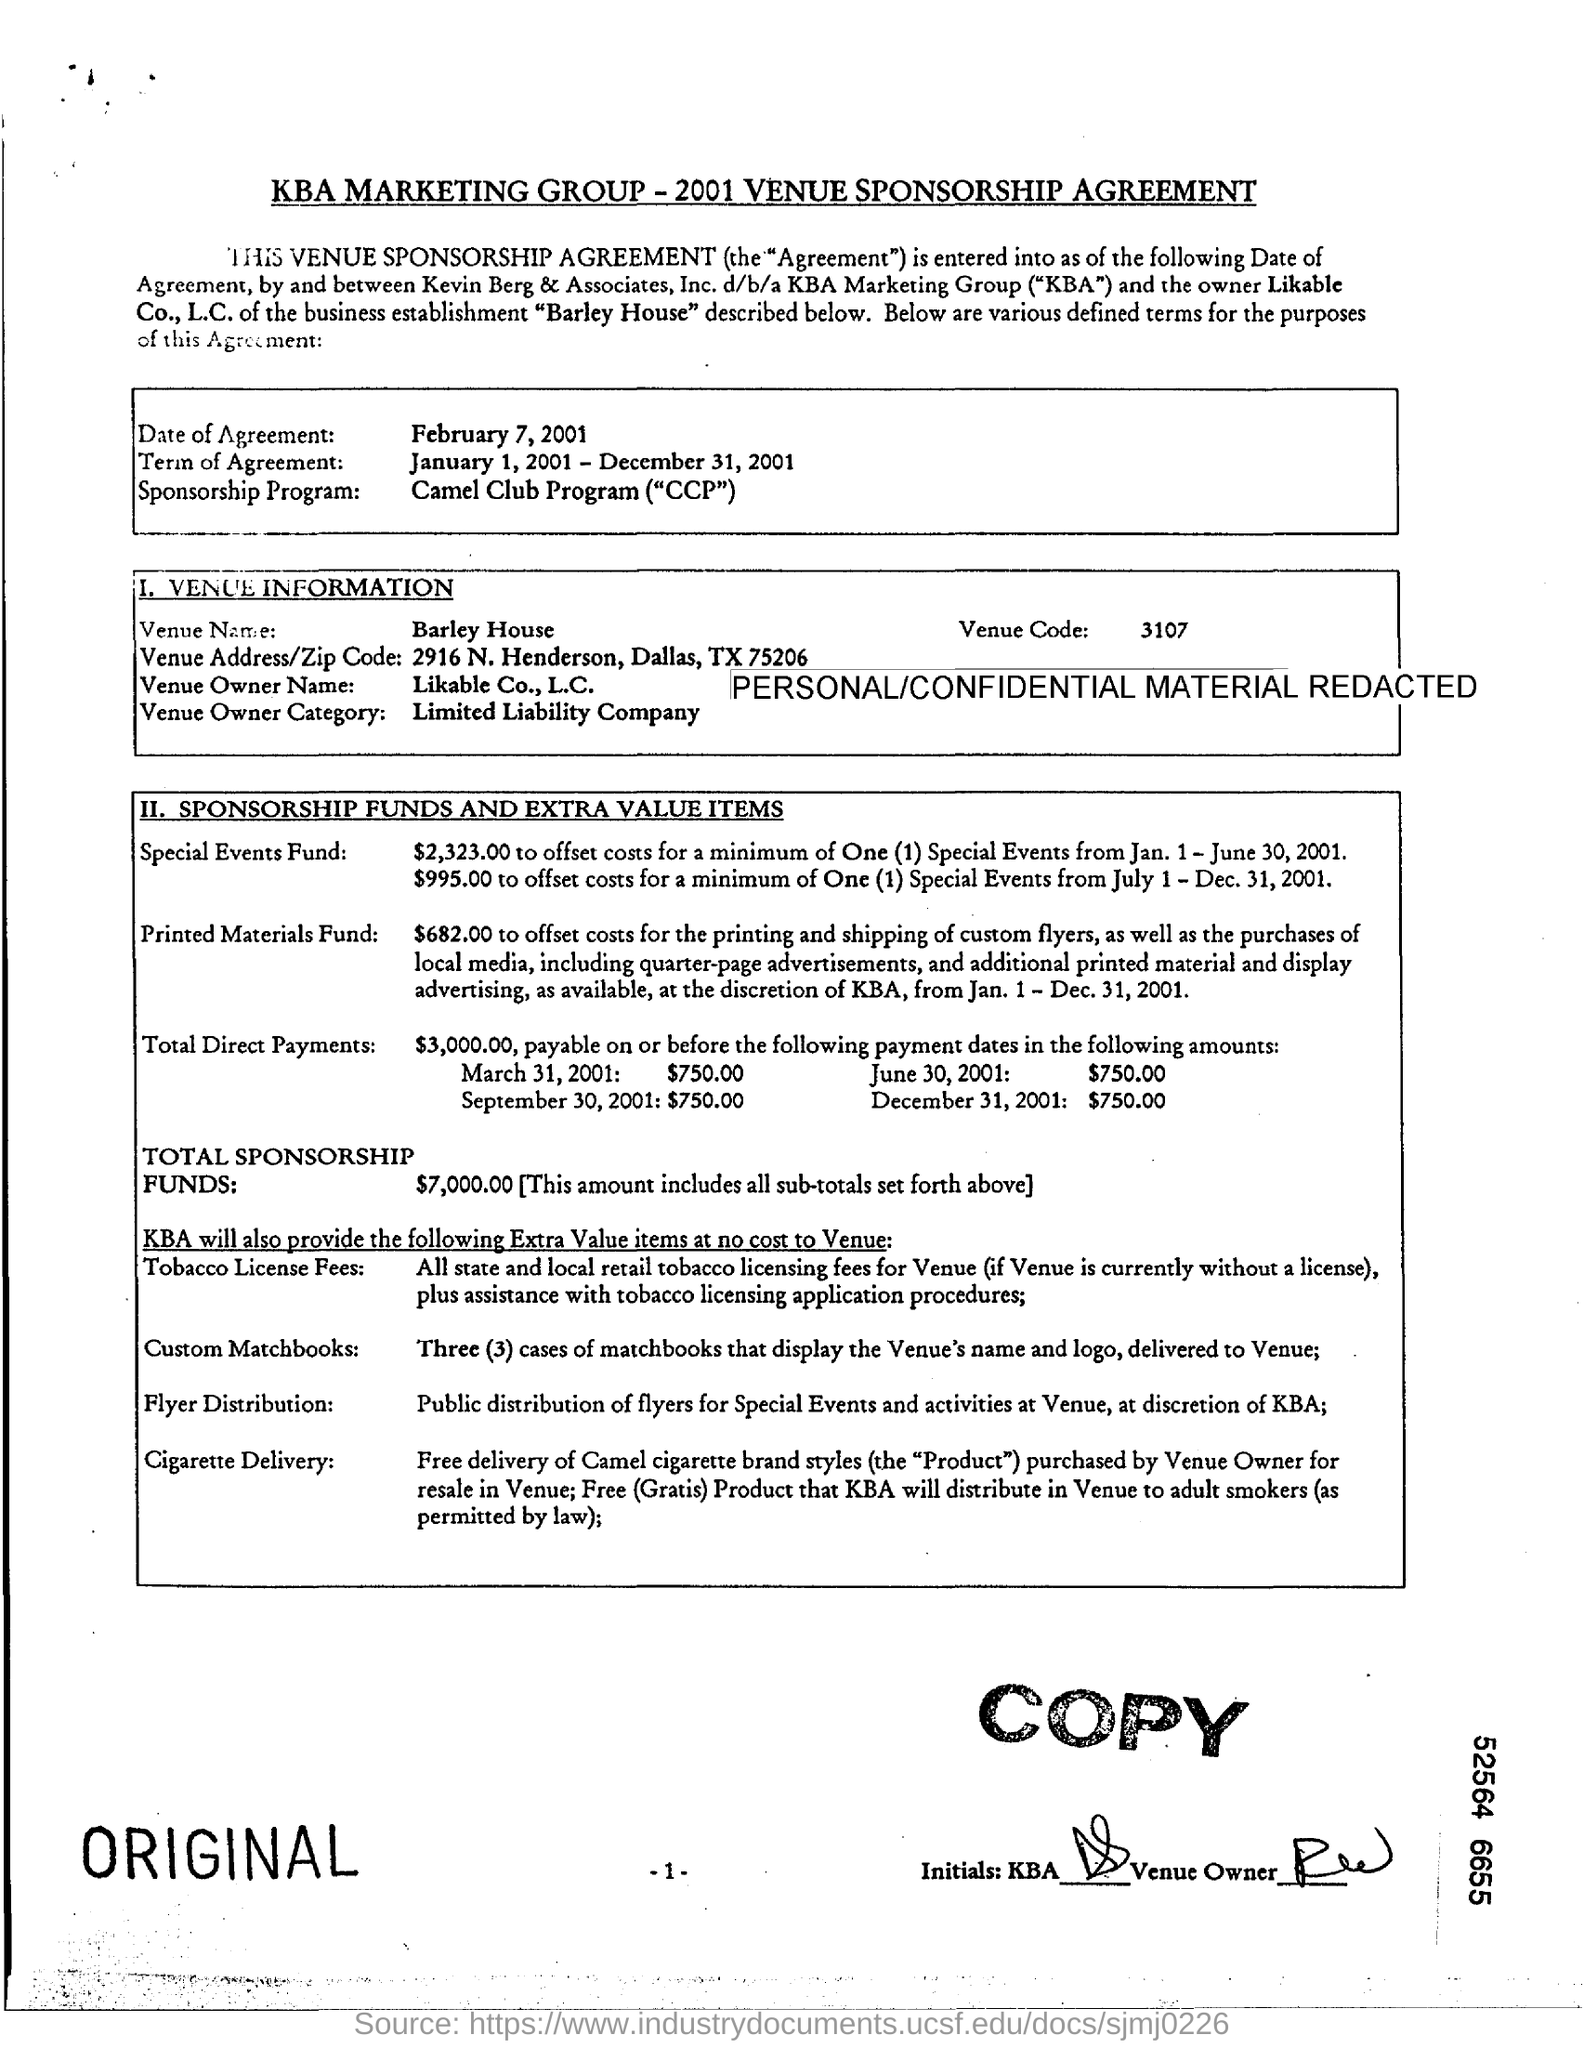What is the document title?
Offer a terse response. KBA MARKETING GROUP-2001 VENUE SPONSORSHIP AGREEMENT. What is the date of agreement?
Give a very brief answer. February 7, 2001. What is the sponsorship program name?
Provide a succinct answer. Camel Club Program ("CCP"). How much is the total sponsorship funds?
Ensure brevity in your answer.  $7,000.00. What is the venue code?
Provide a short and direct response. 3107. 